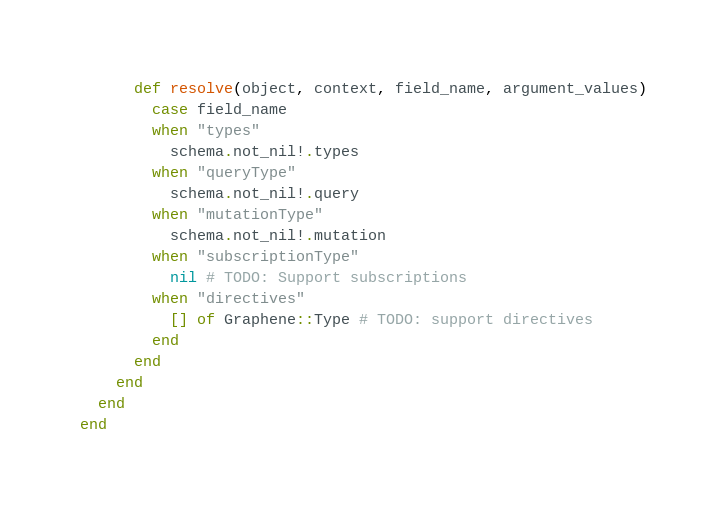<code> <loc_0><loc_0><loc_500><loc_500><_Crystal_>      def resolve(object, context, field_name, argument_values)
        case field_name
        when "types"
          schema.not_nil!.types
        when "queryType"
          schema.not_nil!.query
        when "mutationType"
          schema.not_nil!.mutation
        when "subscriptionType"
          nil # TODO: Support subscriptions
        when "directives"
          [] of Graphene::Type # TODO: support directives
        end
      end
    end
  end
end</code> 